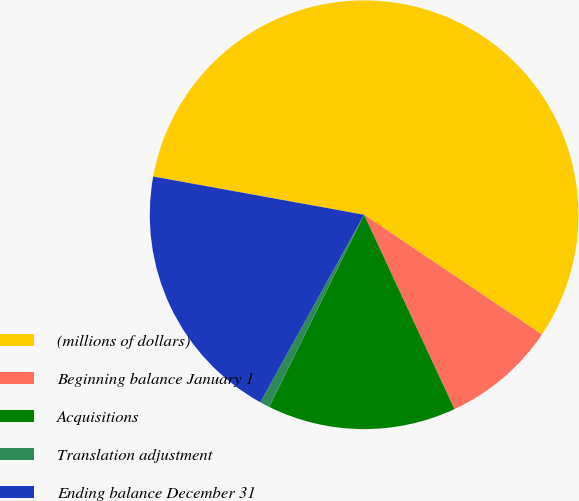Convert chart. <chart><loc_0><loc_0><loc_500><loc_500><pie_chart><fcel>(millions of dollars)<fcel>Beginning balance January 1<fcel>Acquisitions<fcel>Translation adjustment<fcel>Ending balance December 31<nl><fcel>56.58%<fcel>8.64%<fcel>14.23%<fcel>0.74%<fcel>19.81%<nl></chart> 